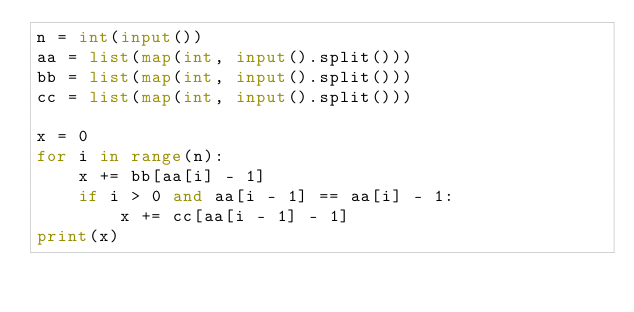<code> <loc_0><loc_0><loc_500><loc_500><_Python_>n = int(input())
aa = list(map(int, input().split()))
bb = list(map(int, input().split()))
cc = list(map(int, input().split()))

x = 0
for i in range(n):
    x += bb[aa[i] - 1]
    if i > 0 and aa[i - 1] == aa[i] - 1:
        x += cc[aa[i - 1] - 1]
print(x)</code> 